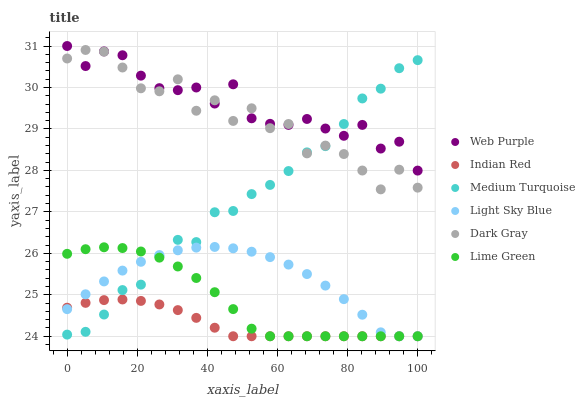Does Indian Red have the minimum area under the curve?
Answer yes or no. Yes. Does Web Purple have the maximum area under the curve?
Answer yes or no. Yes. Does Dark Gray have the minimum area under the curve?
Answer yes or no. No. Does Dark Gray have the maximum area under the curve?
Answer yes or no. No. Is Indian Red the smoothest?
Answer yes or no. Yes. Is Dark Gray the roughest?
Answer yes or no. Yes. Is Web Purple the smoothest?
Answer yes or no. No. Is Web Purple the roughest?
Answer yes or no. No. Does Indian Red have the lowest value?
Answer yes or no. Yes. Does Dark Gray have the lowest value?
Answer yes or no. No. Does Web Purple have the highest value?
Answer yes or no. Yes. Does Dark Gray have the highest value?
Answer yes or no. No. Is Light Sky Blue less than Web Purple?
Answer yes or no. Yes. Is Web Purple greater than Lime Green?
Answer yes or no. Yes. Does Medium Turquoise intersect Lime Green?
Answer yes or no. Yes. Is Medium Turquoise less than Lime Green?
Answer yes or no. No. Is Medium Turquoise greater than Lime Green?
Answer yes or no. No. Does Light Sky Blue intersect Web Purple?
Answer yes or no. No. 